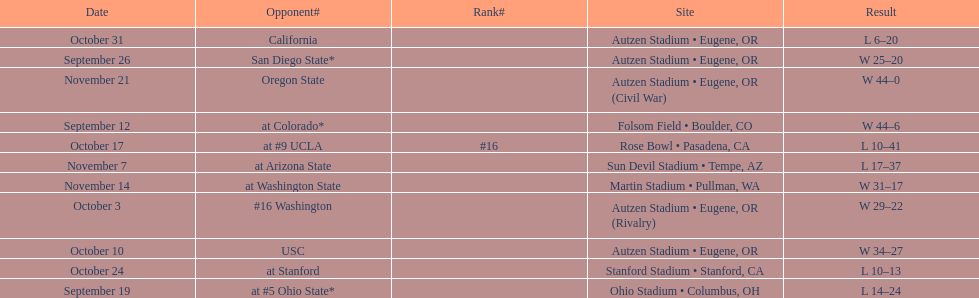Who was their last opponent of the season? Oregon State. Write the full table. {'header': ['Date', 'Opponent#', 'Rank#', 'Site', 'Result'], 'rows': [['October 31', 'California', '', 'Autzen Stadium • Eugene, OR', 'L\xa06–20'], ['September 26', 'San Diego State*', '', 'Autzen Stadium • Eugene, OR', 'W\xa025–20'], ['November 21', 'Oregon State', '', 'Autzen Stadium • Eugene, OR (Civil War)', 'W\xa044–0'], ['September 12', 'at\xa0Colorado*', '', 'Folsom Field • Boulder, CO', 'W\xa044–6'], ['October 17', 'at\xa0#9\xa0UCLA', '#16', 'Rose Bowl • Pasadena, CA', 'L\xa010–41'], ['November 7', 'at\xa0Arizona State', '', 'Sun Devil Stadium • Tempe, AZ', 'L\xa017–37'], ['November 14', 'at\xa0Washington State', '', 'Martin Stadium • Pullman, WA', 'W\xa031–17'], ['October 3', '#16\xa0Washington', '', 'Autzen Stadium • Eugene, OR (Rivalry)', 'W\xa029–22'], ['October 10', 'USC', '', 'Autzen Stadium • Eugene, OR', 'W\xa034–27'], ['October 24', 'at\xa0Stanford', '', 'Stanford Stadium • Stanford, CA', 'L\xa010–13'], ['September 19', 'at\xa0#5\xa0Ohio State*', '', 'Ohio Stadium • Columbus, OH', 'L\xa014–24']]} 